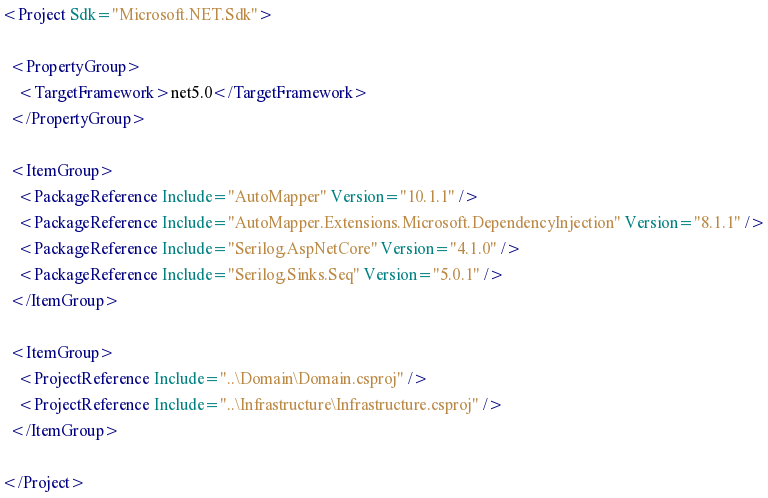Convert code to text. <code><loc_0><loc_0><loc_500><loc_500><_XML_><Project Sdk="Microsoft.NET.Sdk">

  <PropertyGroup>
    <TargetFramework>net5.0</TargetFramework>
  </PropertyGroup>

  <ItemGroup>
    <PackageReference Include="AutoMapper" Version="10.1.1" />
    <PackageReference Include="AutoMapper.Extensions.Microsoft.DependencyInjection" Version="8.1.1" />
    <PackageReference Include="Serilog.AspNetCore" Version="4.1.0" />
    <PackageReference Include="Serilog.Sinks.Seq" Version="5.0.1" />
  </ItemGroup>

  <ItemGroup>
    <ProjectReference Include="..\Domain\Domain.csproj" />
    <ProjectReference Include="..\Infrastructure\Infrastructure.csproj" />
  </ItemGroup>

</Project>
</code> 